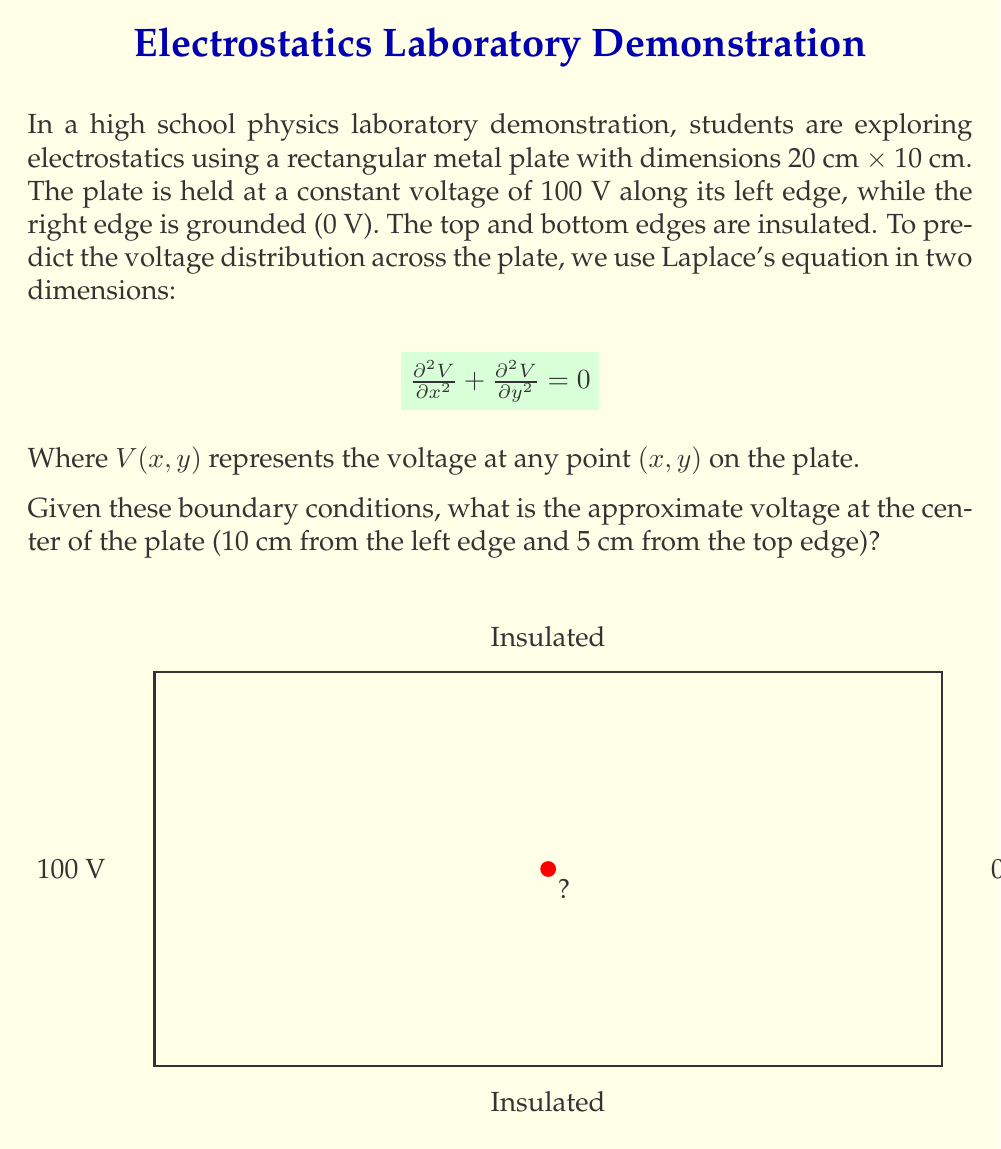Show me your answer to this math problem. To solve this problem, we'll use the analytical solution for Laplace's equation in a rectangular domain with the given boundary conditions. The solution is:

$$V(x,y) = \sum_{n=1,3,5,...}^{\infty} \frac{4V_0}{n\pi} \sin\left(\frac{n\pi x}{L}\right) \sinh\left(\frac{n\pi y}{L}\right) \frac{1}{\sinh\left(\frac{n\pi W}{L}\right)}$$

Where:
- $V_0 = 100$ V (voltage at the left edge)
- $L = 20$ cm (length of the plate)
- $W = 10$ cm (width of the plate)
- $(x,y) = (10, 5)$ cm (coordinates of the center point)

Steps to solve:

1) We'll use the first few terms of the series for a good approximation. Let's use n = 1, 3, and 5.

2) For n = 1:
   $$\frac{4 \cdot 100}{1\pi} \sin\left(\frac{1\pi \cdot 10}{20}\right) \sinh\left(\frac{1\pi \cdot 5}{20}\right) \frac{1}{\sinh\left(\frac{1\pi \cdot 10}{20}\right)} \approx 50.00$$

3) For n = 3:
   $$\frac{4 \cdot 100}{3\pi} \sin\left(\frac{3\pi \cdot 10}{20}\right) \sinh\left(\frac{3\pi \cdot 5}{20}\right) \frac{1}{\sinh\left(\frac{3\pi \cdot 10}{20}\right)} \approx 0.00$$

4) For n = 5:
   $$\frac{4 \cdot 100}{5\pi} \sin\left(\frac{5\pi \cdot 10}{20}\right) \sinh\left(\frac{5\pi \cdot 5}{20}\right) \frac{1}{\sinh\left(\frac{5\pi \cdot 10}{20}\right)} \approx 0.00$$

5) Summing these terms:
   $50.00 + 0.00 + 0.00 = 50.00$ V

Therefore, the voltage at the center of the plate is approximately 50 V.
Answer: 50 V 